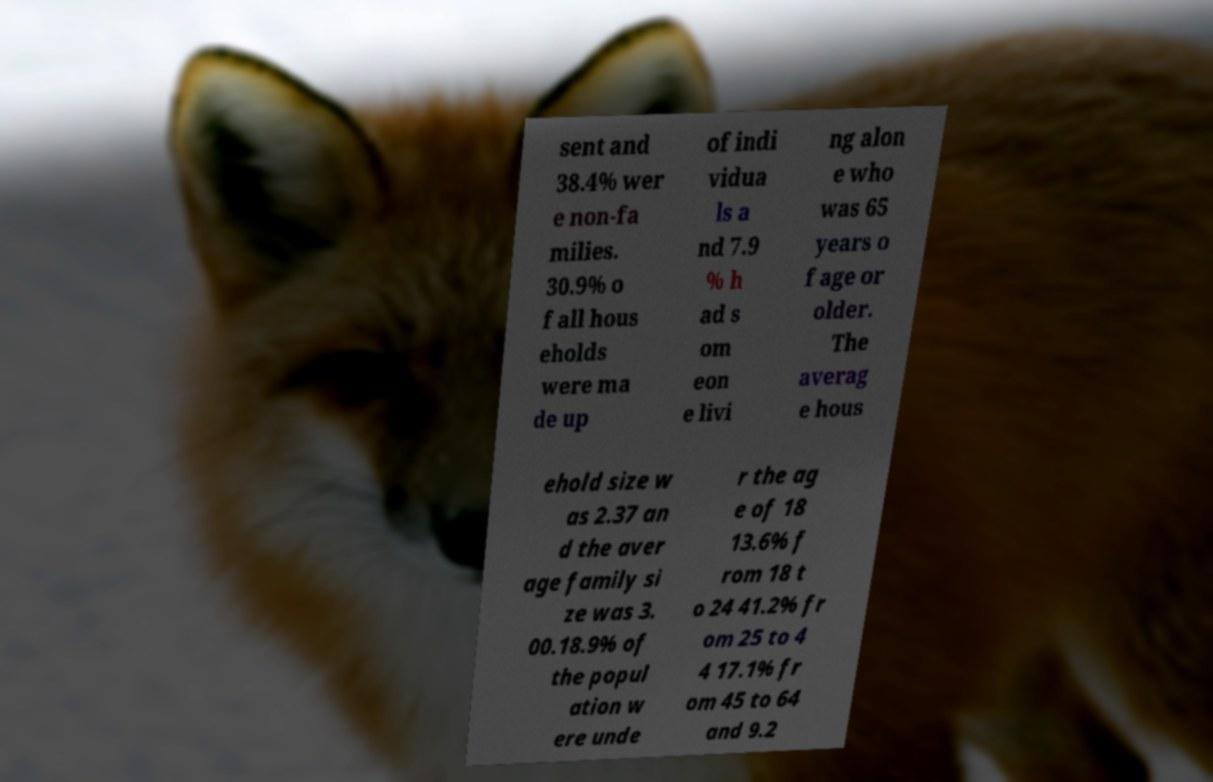For documentation purposes, I need the text within this image transcribed. Could you provide that? sent and 38.4% wer e non-fa milies. 30.9% o f all hous eholds were ma de up of indi vidua ls a nd 7.9 % h ad s om eon e livi ng alon e who was 65 years o f age or older. The averag e hous ehold size w as 2.37 an d the aver age family si ze was 3. 00.18.9% of the popul ation w ere unde r the ag e of 18 13.6% f rom 18 t o 24 41.2% fr om 25 to 4 4 17.1% fr om 45 to 64 and 9.2 